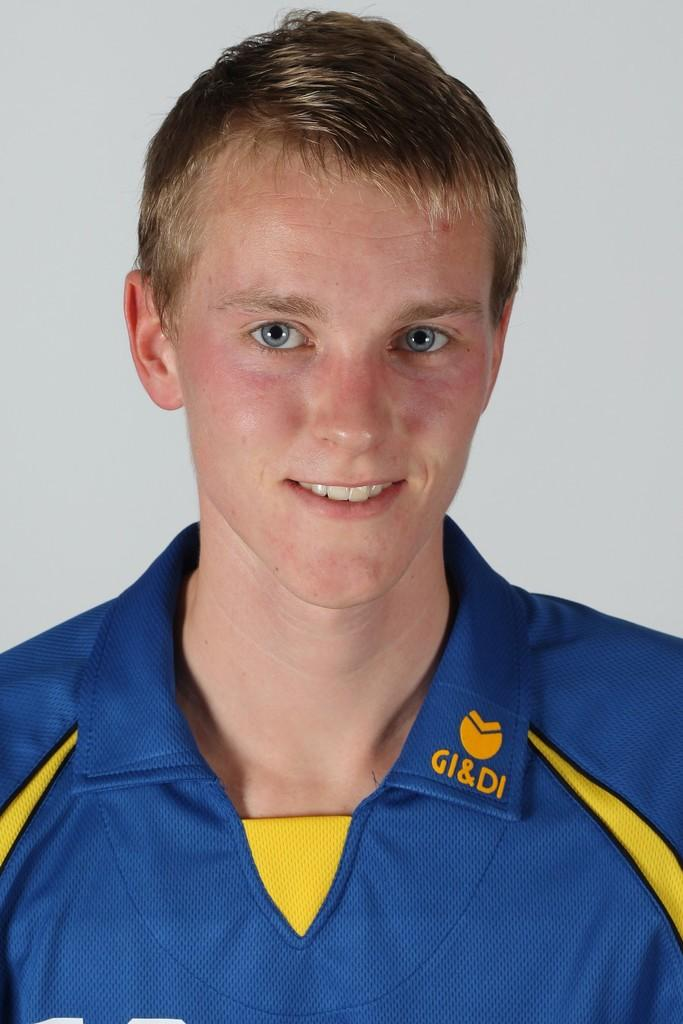Provide a one-sentence caption for the provided image. The young man pictured has the letters GI&DI embroidered on his collar. 